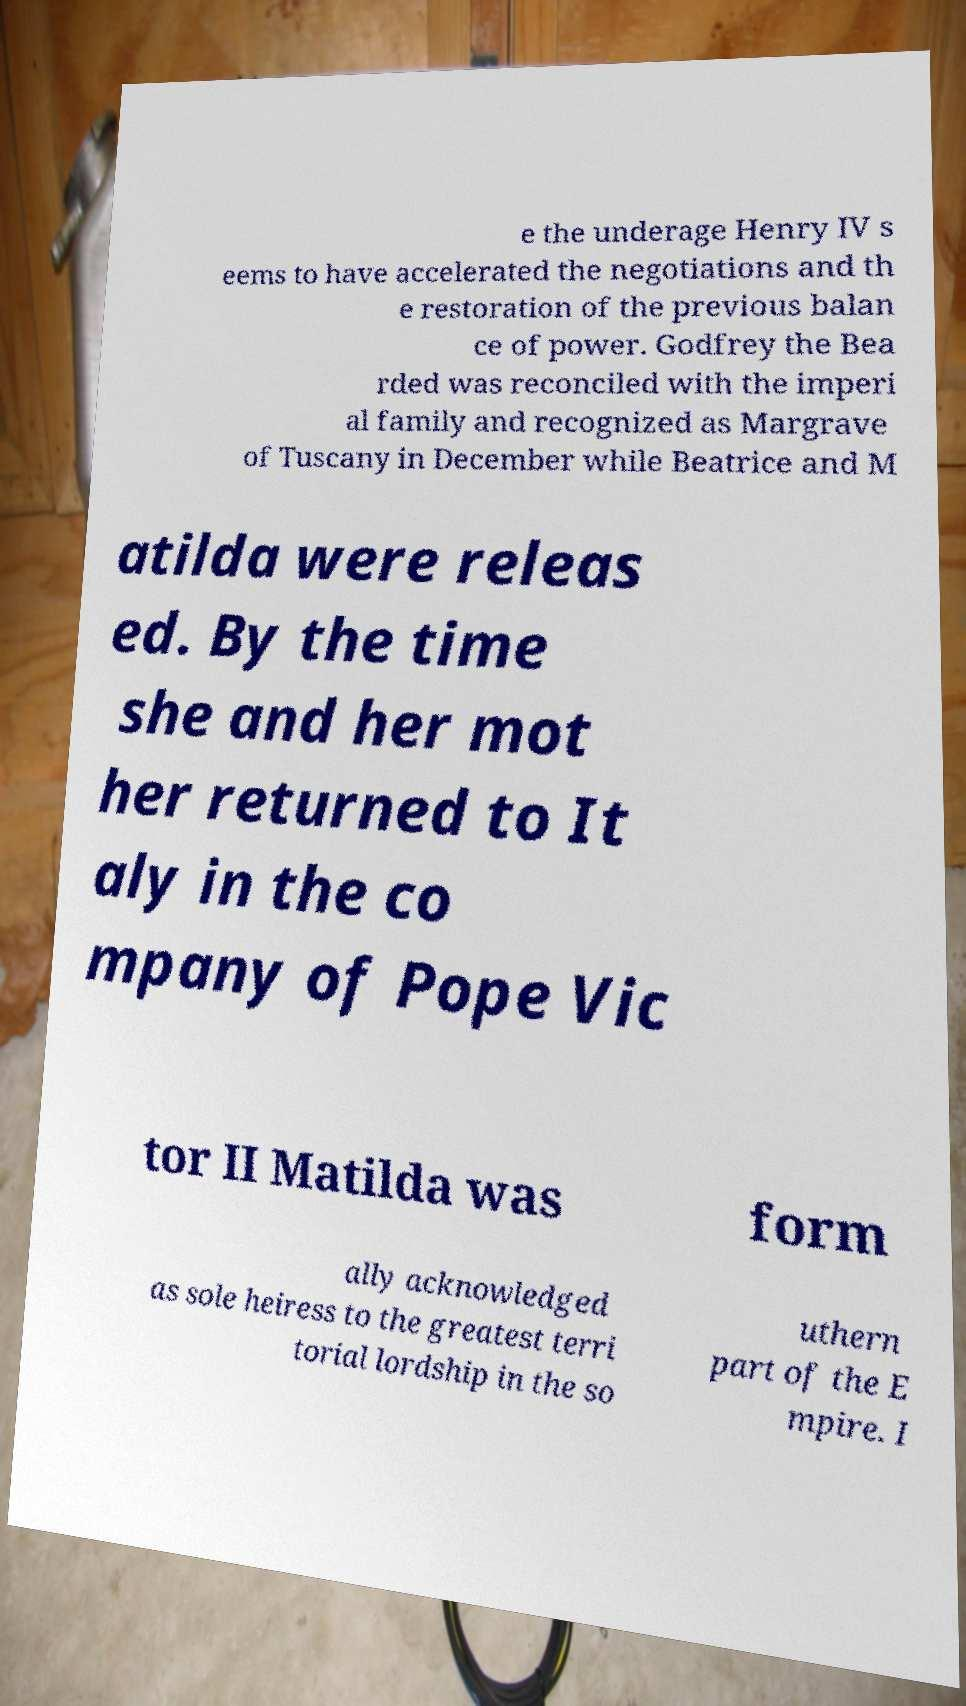There's text embedded in this image that I need extracted. Can you transcribe it verbatim? e the underage Henry IV s eems to have accelerated the negotiations and th e restoration of the previous balan ce of power. Godfrey the Bea rded was reconciled with the imperi al family and recognized as Margrave of Tuscany in December while Beatrice and M atilda were releas ed. By the time she and her mot her returned to It aly in the co mpany of Pope Vic tor II Matilda was form ally acknowledged as sole heiress to the greatest terri torial lordship in the so uthern part of the E mpire. I 